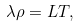Convert formula to latex. <formula><loc_0><loc_0><loc_500><loc_500>\lambda \rho = L T ,</formula> 